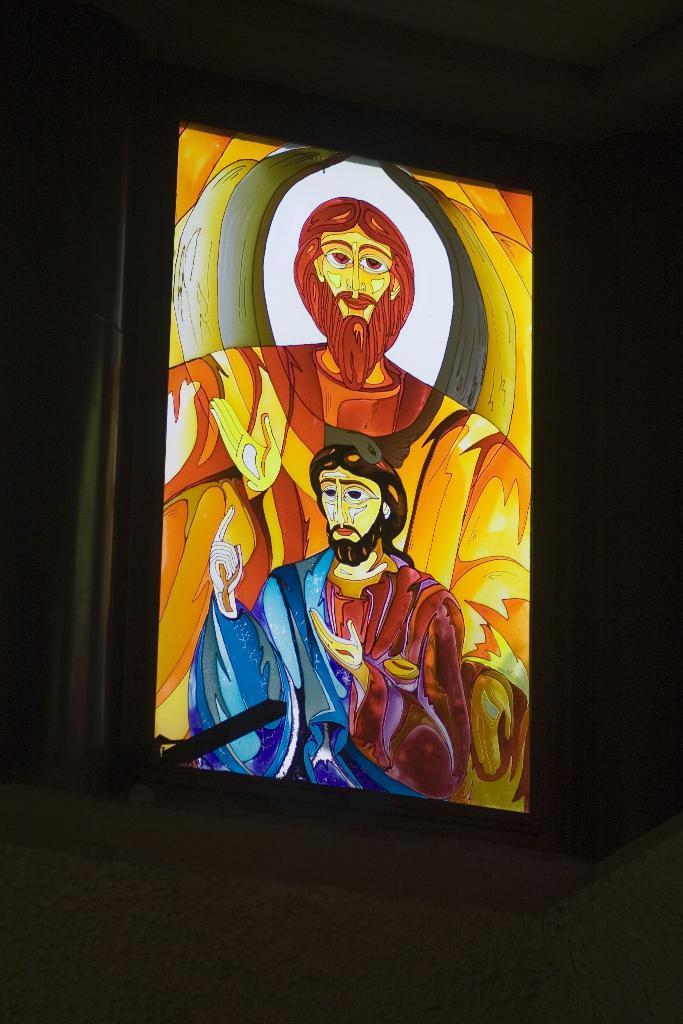How would you summarize this image in a sentence or two? In this image I can see a photo frame of two persons which is brown, yellow, blue, white, black and maroon in color. I can see the black colored background. 